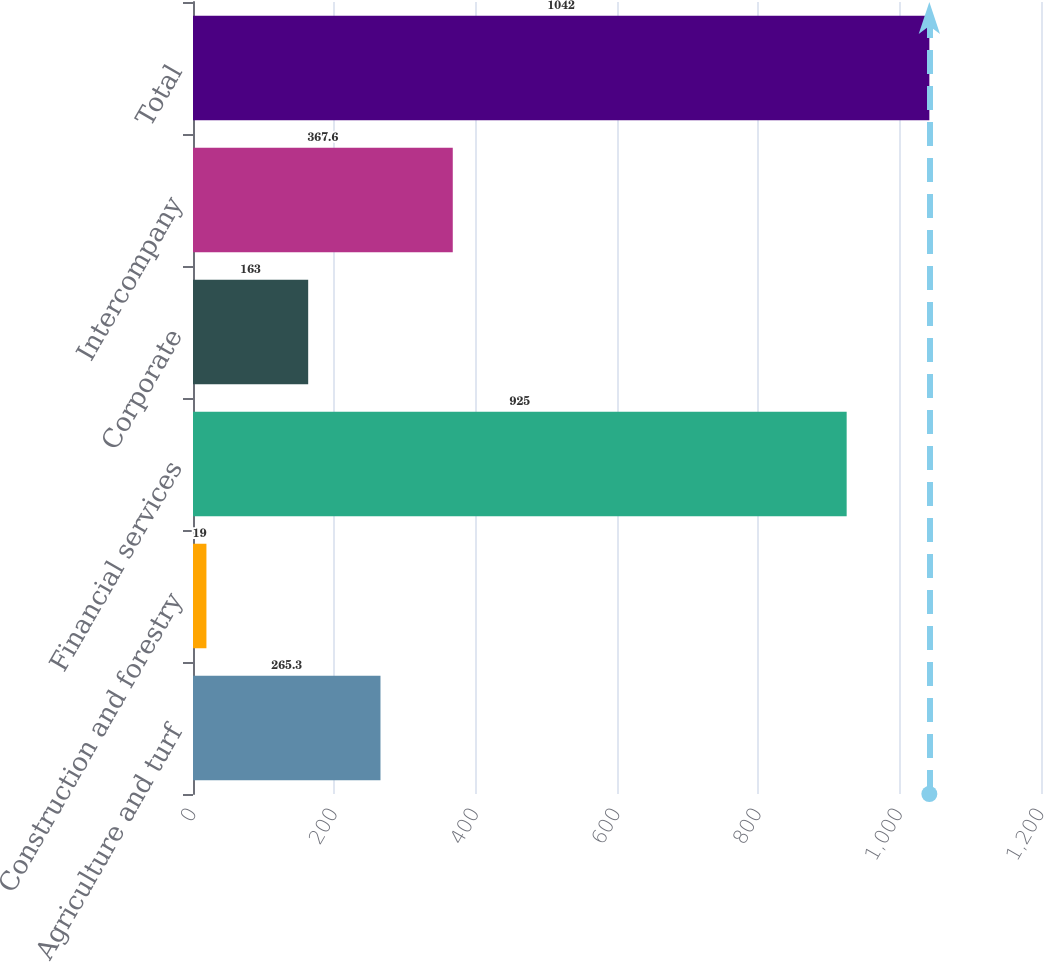Convert chart to OTSL. <chart><loc_0><loc_0><loc_500><loc_500><bar_chart><fcel>Agriculture and turf<fcel>Construction and forestry<fcel>Financial services<fcel>Corporate<fcel>Intercompany<fcel>Total<nl><fcel>265.3<fcel>19<fcel>925<fcel>163<fcel>367.6<fcel>1042<nl></chart> 